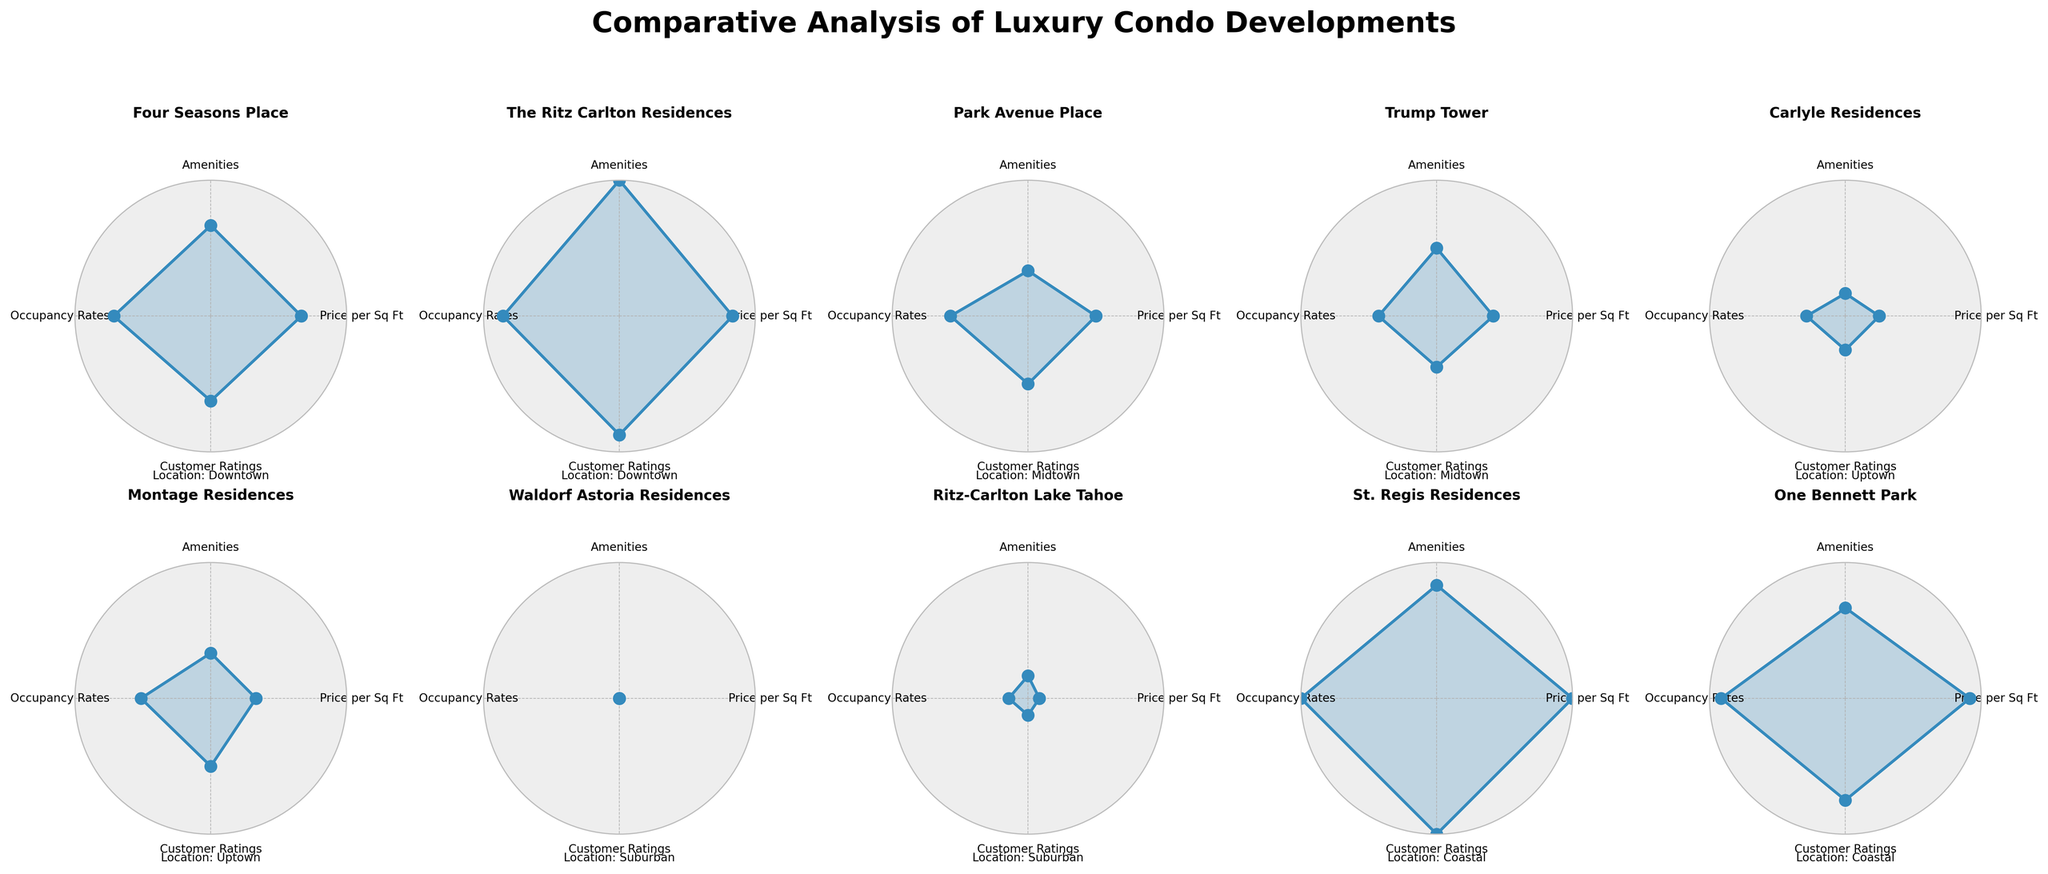What project has the highest Customer Ratings? By looking at the subplots, we see that 'St. Regis Residences' has the highest Customer Ratings, indicated by its arc reaching furthest around the radar chart.
Answer: St. Regis Residences Which project scores the lowest in Price per Sq Ft? The 'Waldorf Astoria Residences' in the Suburban area has the lowest Price per Sq Ft, as this point is closest to the center of its radar chart.
Answer: Waldorf Astoria Residences What project in Midtown has the highest Occupancy Rates? Among the Midtown projects ('Park Avenue Place' and 'Trump Tower'), 'Park Avenue Place' shows higher Occupancy Rates as its arc extends more outward in the Occupancy Rates axis.
Answer: Park Avenue Place Compare the Amenities between the 'Four Seasons Place' and 'The Ritz Carlton Residences'. 'The Ritz Carlton Residences' scores slightly higher in Amenities compared to 'Four Seasons Place', as indicated by a wider arc in the Amenities axis.
Answer: The Ritz Carlton Residences Which project leads in all categories for the Coastal location? Observing both Coastal projects ('St. Regis Residences' and 'One Bennett Park'), 'St. Regis Residences' leads in Price per Sq Ft, Amenities, Occupancy Rates, and Customer Ratings as it has more extensive arcs in all categories.
Answer: St. Regis Residences How does 'Montage Residences' compare to 'Carlyle Residences' in terms of Customer Ratings? 'Montage Residences' has slightly higher Customer Ratings than 'Carlyle Residences', as indicated by a slightly larger outward arc on the Customer Ratings axis.
Answer: Montage Residences Which project has the highest number of Amenities? By examining the radar charts, 'The Ritz Carlton Residences' has the highest number of Amenities with the highest point on the Amenities axis.
Answer: The Ritz Carlton Residences What are the differences in Occupancy Rates and Customer Ratings between 'Trump Tower' and 'Carlyle Residences'? 'Trump Tower' has a higher Occupancy Rates, while 'Carlyle Residences' has a higher Customer Rating. This is shown by 'Trump Tower' having a more extensive arc in Occupancy Rates and 'Carlyle Residences' in Customer Ratings.
Answer: Trump Tower: higher Occupancy Rates, Carlyle Residences: higher Customer Ratings 